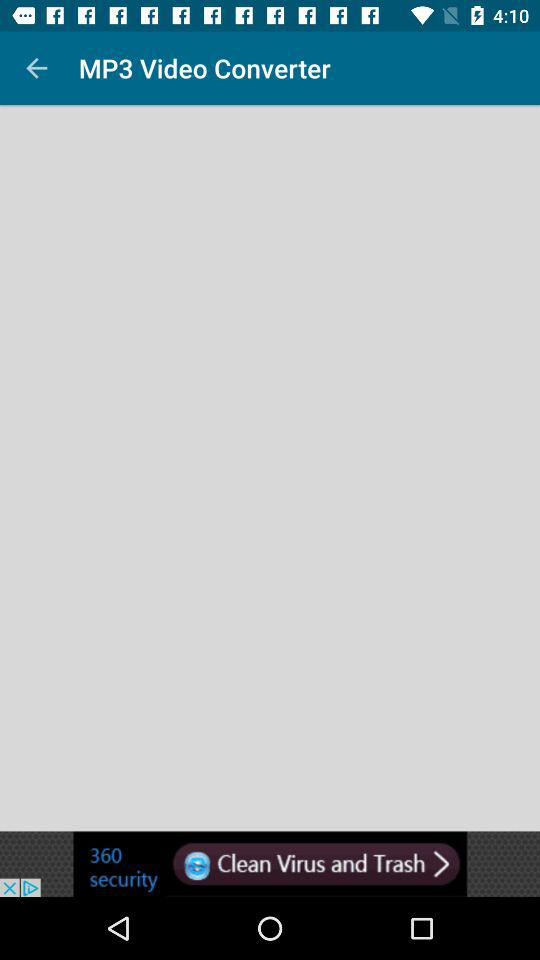What is the application name? The application name is "MP3 Video Converter". 